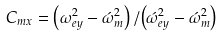Convert formula to latex. <formula><loc_0><loc_0><loc_500><loc_500>C _ { m x } = \left ( \omega _ { e y } ^ { 2 } - \acute { \omega } _ { m } ^ { 2 } \right ) / { \left ( \acute { \omega } _ { e y } ^ { 2 } - \acute { \omega } _ { m } ^ { 2 } \right ) }</formula> 